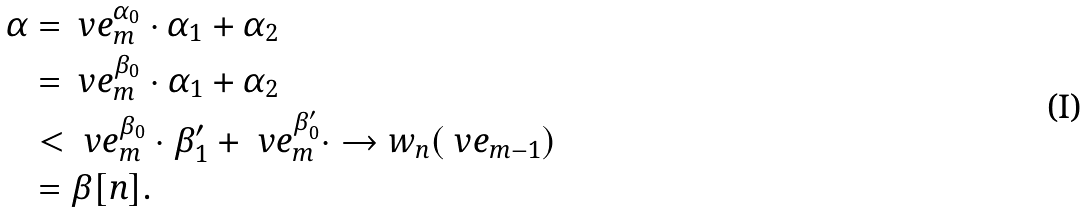<formula> <loc_0><loc_0><loc_500><loc_500>\alpha & = \ v e _ { m } ^ { \alpha _ { 0 } } \cdot \alpha _ { 1 } + \alpha _ { 2 } \\ & = \ v e _ { m } ^ { \beta _ { 0 } } \cdot \alpha _ { 1 } + \alpha _ { 2 } \\ & < \ v e _ { m } ^ { \beta _ { 0 } } \cdot \beta _ { 1 } ^ { \prime } + \ v e _ { m } ^ { \beta _ { 0 } ^ { \prime } } \cdot \to w _ { n } ( \ v e _ { m - 1 } ) \\ & = \beta [ n ] .</formula> 